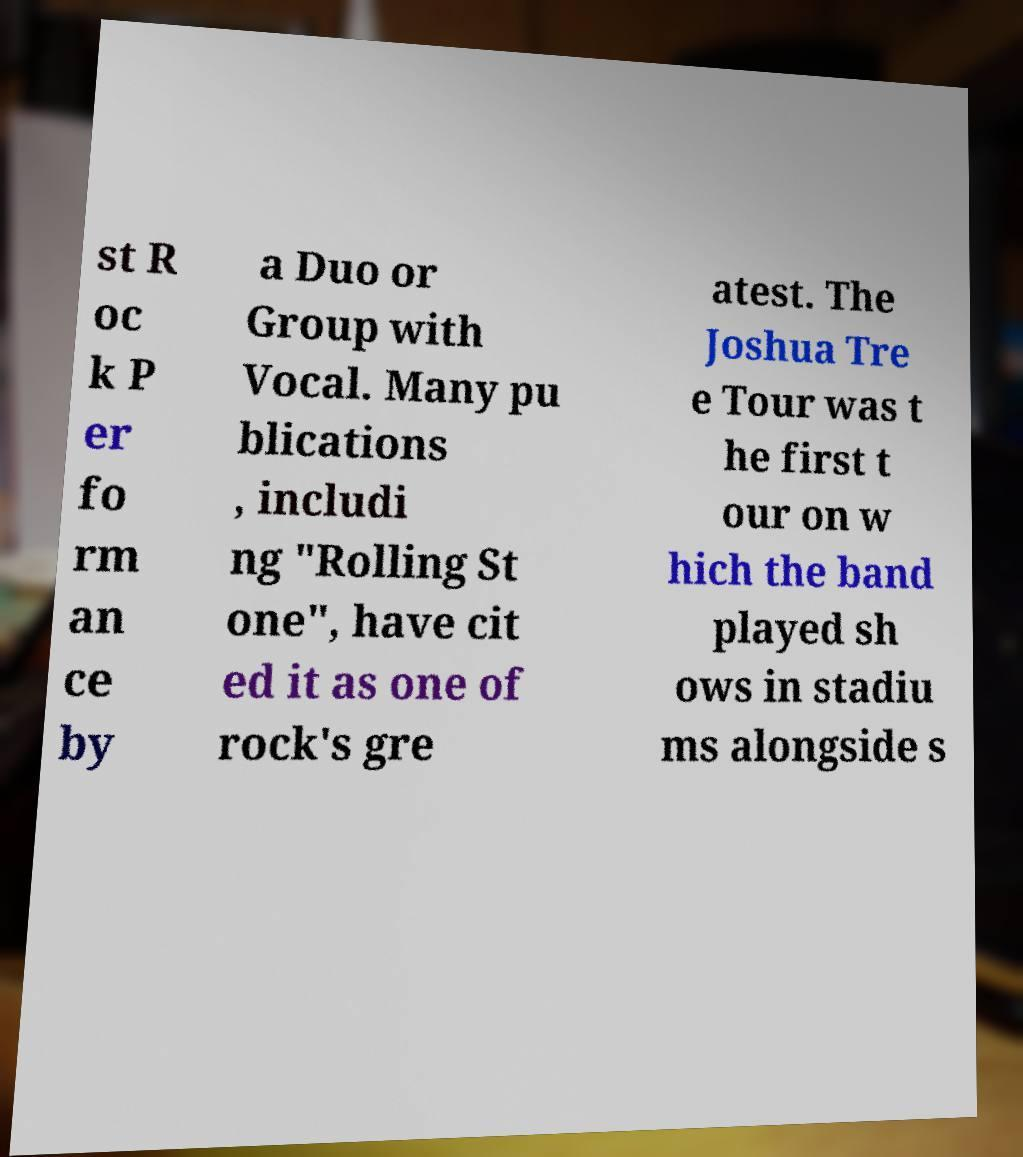Please read and relay the text visible in this image. What does it say? st R oc k P er fo rm an ce by a Duo or Group with Vocal. Many pu blications , includi ng "Rolling St one", have cit ed it as one of rock's gre atest. The Joshua Tre e Tour was t he first t our on w hich the band played sh ows in stadiu ms alongside s 